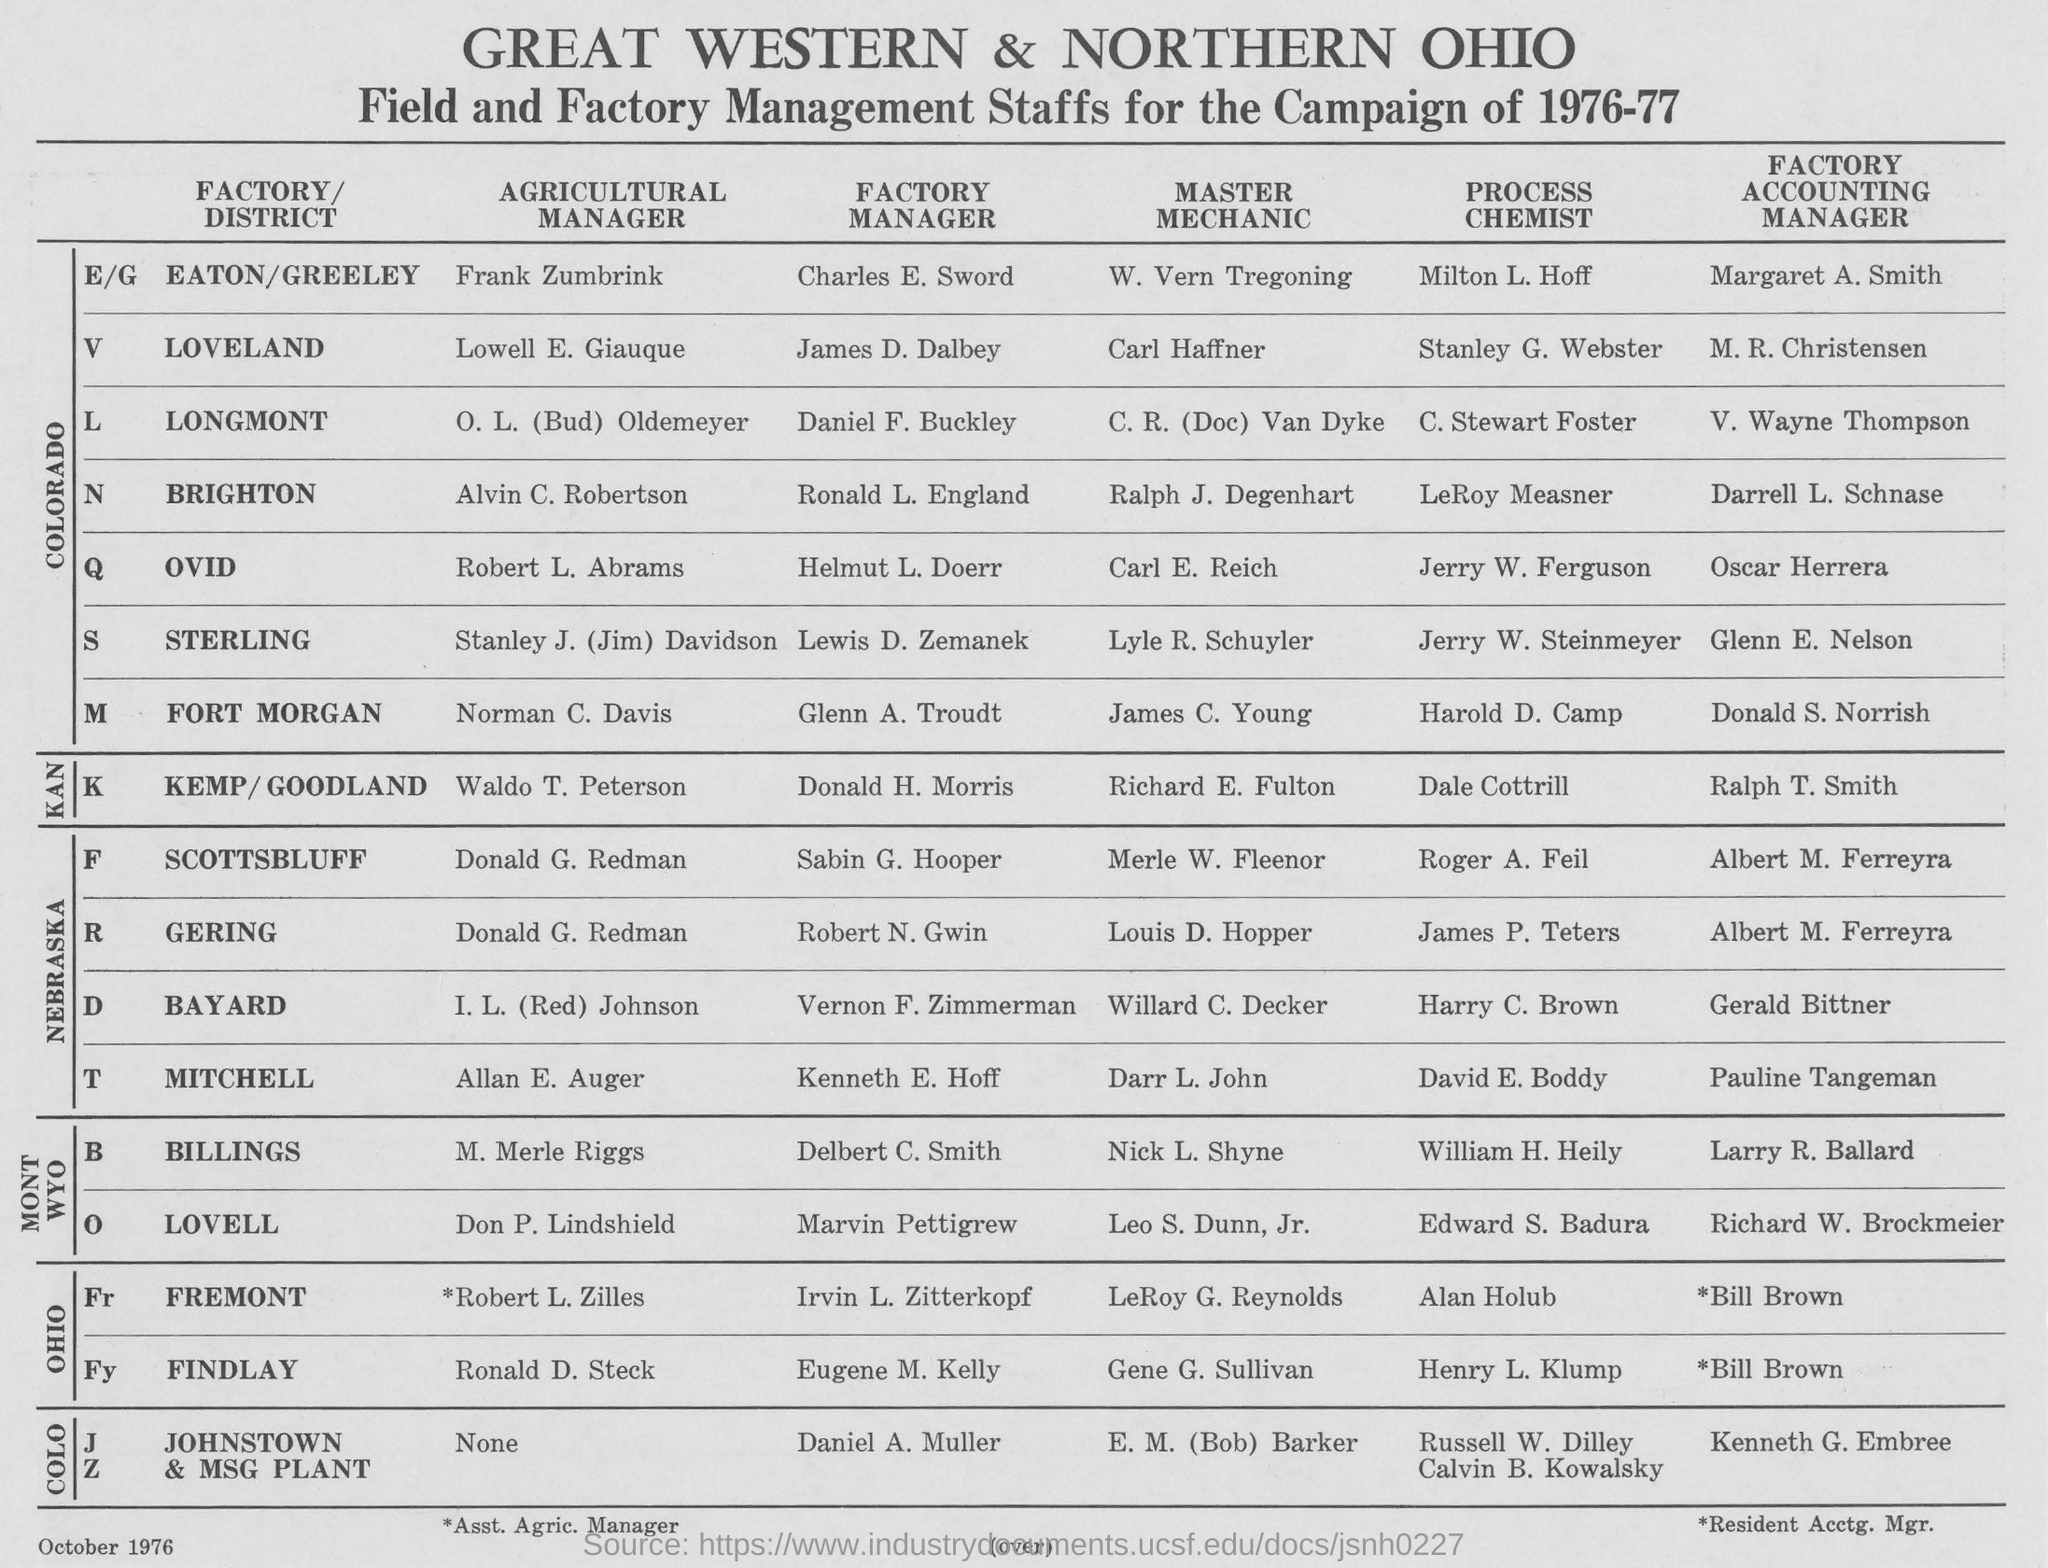Mention a couple of crucial points in this snapshot. The individual who is the factory manager of LOVELL is named MARVIN PETTIGREW. The individual named Gerald Bittner is the Factory Accounting Manager at BAYARD. Carl E. Reich is the Master Mechanic at OVID. The name of the Agricultural Manager of Findlay is Ronald D. Steck. James P. Teters is the process chemist at GERING. 